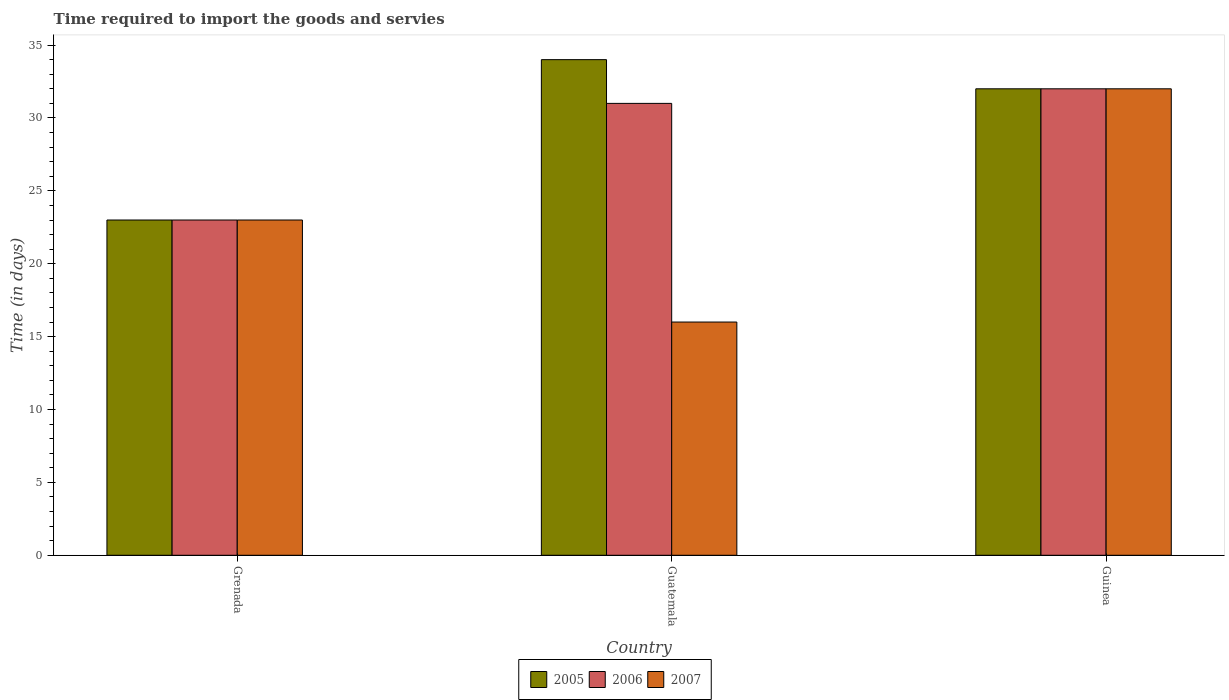How many groups of bars are there?
Keep it short and to the point. 3. Are the number of bars per tick equal to the number of legend labels?
Your answer should be compact. Yes. How many bars are there on the 2nd tick from the left?
Keep it short and to the point. 3. How many bars are there on the 3rd tick from the right?
Provide a short and direct response. 3. What is the label of the 2nd group of bars from the left?
Your answer should be compact. Guatemala. In how many cases, is the number of bars for a given country not equal to the number of legend labels?
Your answer should be very brief. 0. What is the number of days required to import the goods and services in 2007 in Guinea?
Make the answer very short. 32. Across all countries, what is the maximum number of days required to import the goods and services in 2007?
Give a very brief answer. 32. In which country was the number of days required to import the goods and services in 2006 maximum?
Offer a terse response. Guinea. In which country was the number of days required to import the goods and services in 2007 minimum?
Keep it short and to the point. Guatemala. What is the total number of days required to import the goods and services in 2005 in the graph?
Your answer should be very brief. 89. What is the difference between the number of days required to import the goods and services in 2006 in Guinea and the number of days required to import the goods and services in 2007 in Guatemala?
Offer a very short reply. 16. What is the average number of days required to import the goods and services in 2006 per country?
Your answer should be compact. 28.67. In how many countries, is the number of days required to import the goods and services in 2007 greater than 24 days?
Give a very brief answer. 1. What is the ratio of the number of days required to import the goods and services in 2005 in Guatemala to that in Guinea?
Keep it short and to the point. 1.06. Is the number of days required to import the goods and services in 2005 in Guatemala less than that in Guinea?
Your response must be concise. No. Is the difference between the number of days required to import the goods and services in 2005 in Grenada and Guatemala greater than the difference between the number of days required to import the goods and services in 2006 in Grenada and Guatemala?
Make the answer very short. No. What is the difference between the highest and the second highest number of days required to import the goods and services in 2006?
Make the answer very short. 9. What is the difference between the highest and the lowest number of days required to import the goods and services in 2006?
Your answer should be compact. 9. What does the 2nd bar from the left in Guatemala represents?
Your answer should be compact. 2006. Is it the case that in every country, the sum of the number of days required to import the goods and services in 2007 and number of days required to import the goods and services in 2006 is greater than the number of days required to import the goods and services in 2005?
Ensure brevity in your answer.  Yes. How many countries are there in the graph?
Your response must be concise. 3. Does the graph contain any zero values?
Your response must be concise. No. Where does the legend appear in the graph?
Provide a short and direct response. Bottom center. What is the title of the graph?
Offer a very short reply. Time required to import the goods and servies. Does "1999" appear as one of the legend labels in the graph?
Offer a terse response. No. What is the label or title of the X-axis?
Make the answer very short. Country. What is the label or title of the Y-axis?
Give a very brief answer. Time (in days). What is the Time (in days) of 2007 in Grenada?
Offer a terse response. 23. What is the Time (in days) in 2005 in Guatemala?
Your answer should be very brief. 34. What is the Time (in days) of 2007 in Guatemala?
Keep it short and to the point. 16. What is the Time (in days) in 2005 in Guinea?
Your response must be concise. 32. Across all countries, what is the maximum Time (in days) in 2007?
Make the answer very short. 32. Across all countries, what is the minimum Time (in days) in 2005?
Your response must be concise. 23. Across all countries, what is the minimum Time (in days) of 2007?
Ensure brevity in your answer.  16. What is the total Time (in days) in 2005 in the graph?
Offer a terse response. 89. What is the difference between the Time (in days) in 2006 in Grenada and that in Guatemala?
Your answer should be compact. -8. What is the difference between the Time (in days) in 2005 in Grenada and that in Guinea?
Keep it short and to the point. -9. What is the difference between the Time (in days) of 2006 in Grenada and that in Guinea?
Your answer should be very brief. -9. What is the difference between the Time (in days) in 2007 in Grenada and that in Guinea?
Keep it short and to the point. -9. What is the difference between the Time (in days) of 2006 in Guatemala and that in Guinea?
Your answer should be very brief. -1. What is the difference between the Time (in days) of 2006 in Grenada and the Time (in days) of 2007 in Guinea?
Make the answer very short. -9. What is the difference between the Time (in days) of 2006 in Guatemala and the Time (in days) of 2007 in Guinea?
Your answer should be compact. -1. What is the average Time (in days) of 2005 per country?
Keep it short and to the point. 29.67. What is the average Time (in days) in 2006 per country?
Ensure brevity in your answer.  28.67. What is the average Time (in days) of 2007 per country?
Your answer should be very brief. 23.67. What is the difference between the Time (in days) in 2005 and Time (in days) in 2007 in Grenada?
Provide a succinct answer. 0. What is the difference between the Time (in days) in 2005 and Time (in days) in 2006 in Guatemala?
Your answer should be compact. 3. What is the difference between the Time (in days) of 2006 and Time (in days) of 2007 in Guatemala?
Your answer should be very brief. 15. What is the difference between the Time (in days) of 2005 and Time (in days) of 2007 in Guinea?
Give a very brief answer. 0. What is the difference between the Time (in days) of 2006 and Time (in days) of 2007 in Guinea?
Make the answer very short. 0. What is the ratio of the Time (in days) in 2005 in Grenada to that in Guatemala?
Offer a very short reply. 0.68. What is the ratio of the Time (in days) of 2006 in Grenada to that in Guatemala?
Provide a short and direct response. 0.74. What is the ratio of the Time (in days) in 2007 in Grenada to that in Guatemala?
Ensure brevity in your answer.  1.44. What is the ratio of the Time (in days) of 2005 in Grenada to that in Guinea?
Ensure brevity in your answer.  0.72. What is the ratio of the Time (in days) of 2006 in Grenada to that in Guinea?
Ensure brevity in your answer.  0.72. What is the ratio of the Time (in days) in 2007 in Grenada to that in Guinea?
Keep it short and to the point. 0.72. What is the ratio of the Time (in days) in 2005 in Guatemala to that in Guinea?
Offer a very short reply. 1.06. What is the ratio of the Time (in days) of 2006 in Guatemala to that in Guinea?
Make the answer very short. 0.97. What is the difference between the highest and the second highest Time (in days) in 2005?
Provide a succinct answer. 2. What is the difference between the highest and the lowest Time (in days) in 2005?
Provide a short and direct response. 11. What is the difference between the highest and the lowest Time (in days) of 2007?
Your answer should be very brief. 16. 